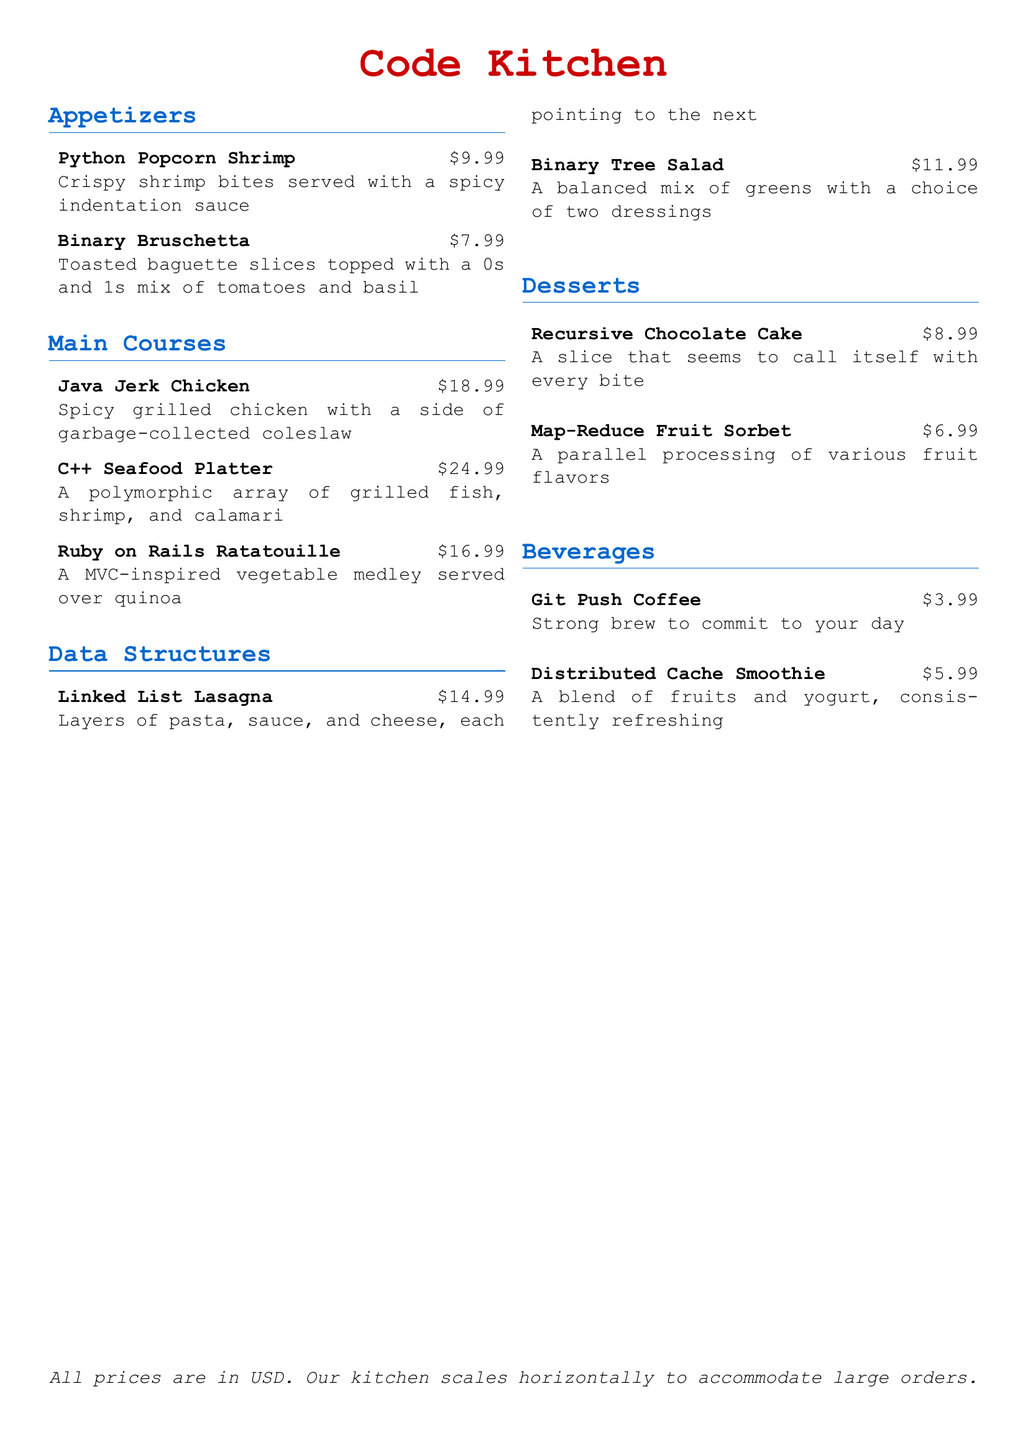What is the name of the appetizer that is served with a spicy indentation sauce? The document lists the appetizer as "Python Popcorn Shrimp" with a description including "spicy indentation sauce."
Answer: Python Popcorn Shrimp What is the price of the C++ Seafood Platter? The price for the C++ Seafood Platter is clearly indicated next to its name in the menu as "$24.99."
Answer: $24.99 What dessert appears to call itself with every bite? The dessert described as "A slice that seems to call itself with every bite" refers to the "Recursive Chocolate Cake."
Answer: Recursive Chocolate Cake How much does the Binary Tree Salad cost? The document states the cost of the Binary Tree Salad, which is listed as "$11.99."
Answer: $11.99 Which beverage is described as a strong brew to commit to your day? "Git Push Coffee" is described as a "strong brew to commit to your day" in the beverages section.
Answer: Git Push Coffee How many main courses are listed on the menu? By counting the items in the "Main Courses" section, there are three main course options mentioned.
Answer: 3 What type of dish is the Distributed Cache Smoothie? The Distributed Cache Smoothie is categorized as a beverage in the menu.
Answer: Beverage What is the theme of the restaurant? The menu items are themed around programming languages and data structures indicating the restaurant’s tech theme.
Answer: Tech-themed What dish features layers of pasta, sauce, and cheese? The dish described with layers of pasta, sauce, and cheese is the "Linked List Lasagna."
Answer: Linked List Lasagna 